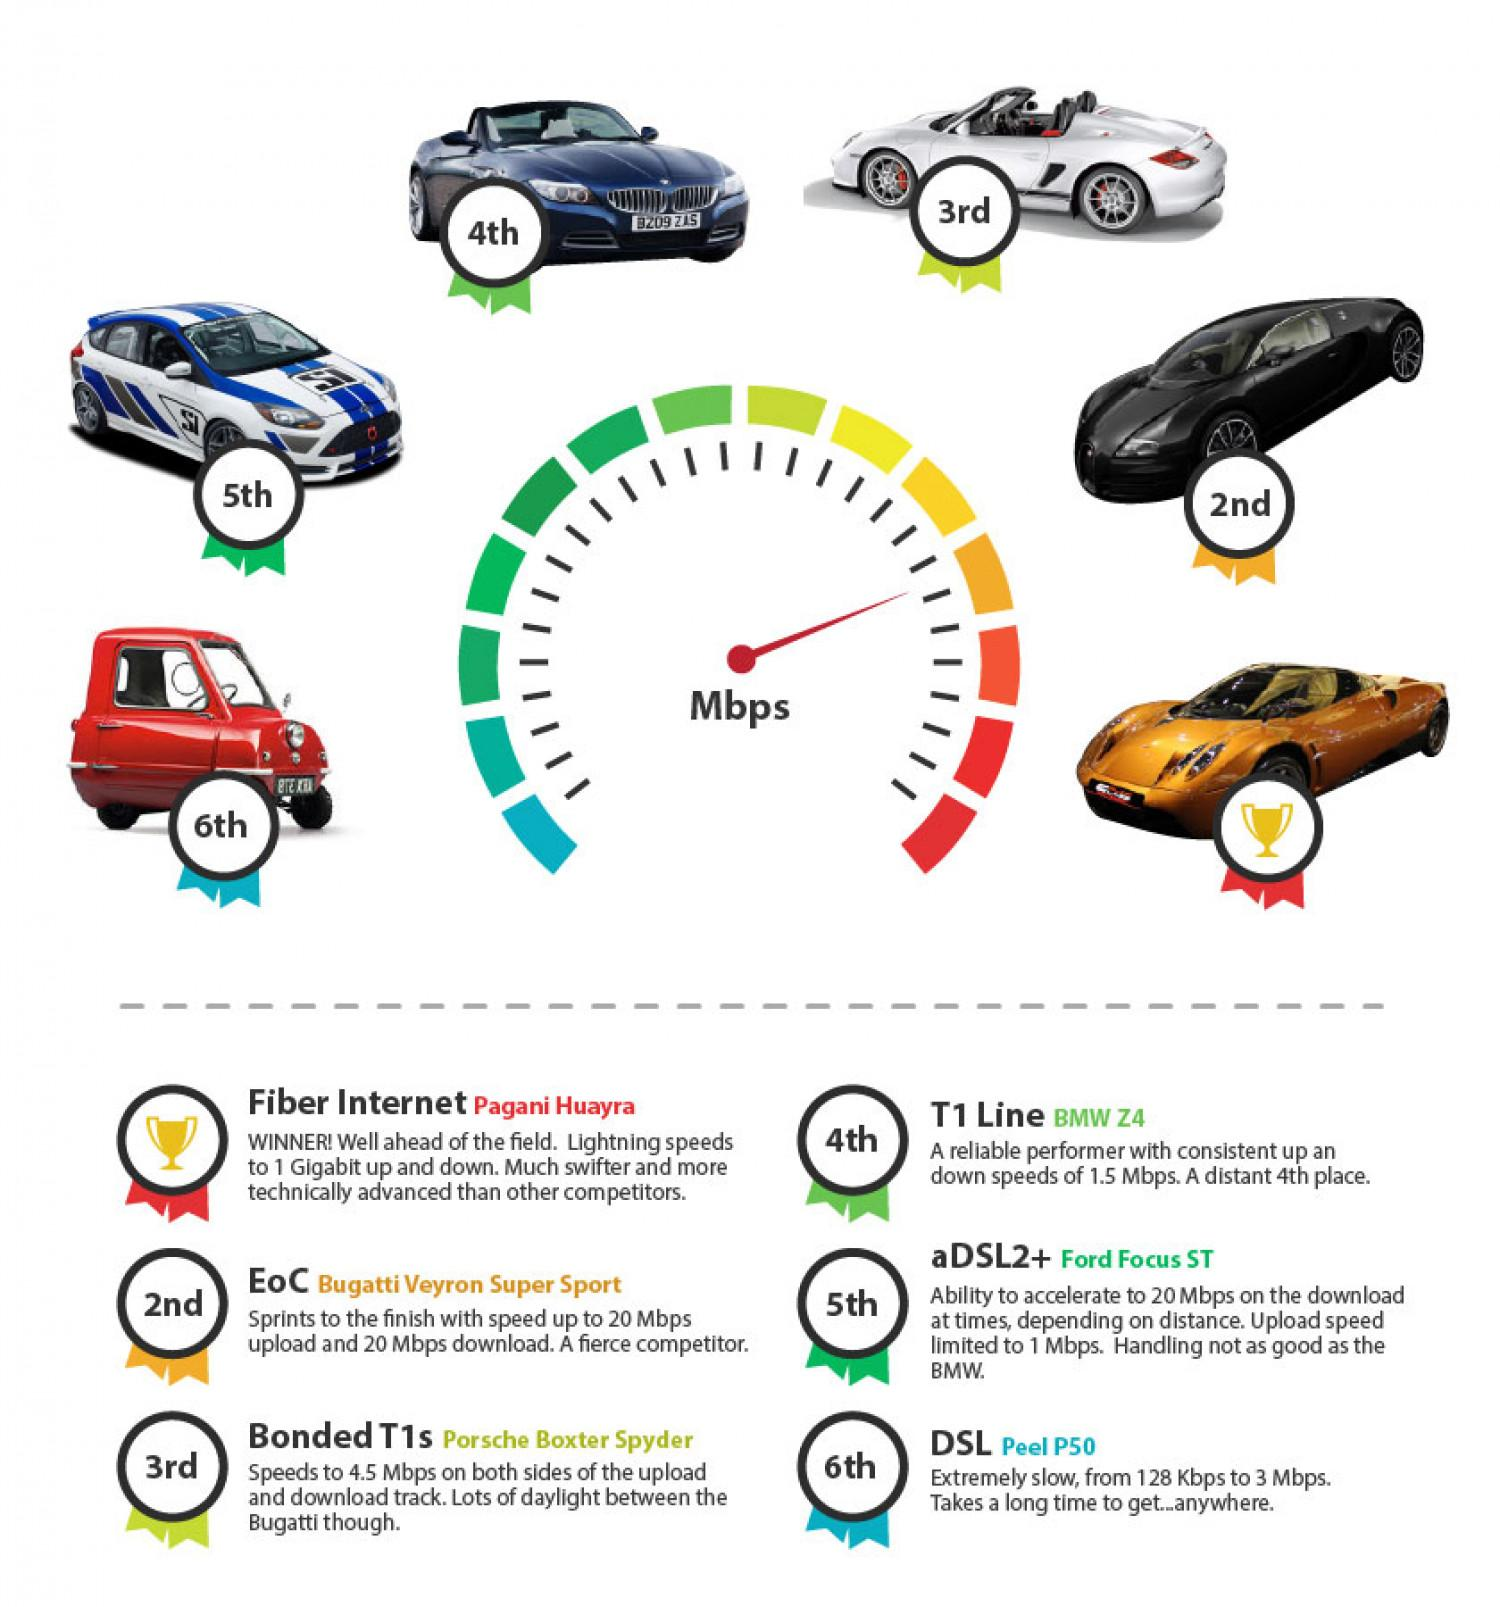Identify some key points in this picture. The white car depicted in the image is a Porsche Boxster Spyder. The color of the car that is first in terms of speed is orange. Six internet service providers are top performers in terms of speed, according to... The black car in the image represents a service provider, and it is not known which specific provider it is. The Pagani Huayra represents the internet service provider with the highest download and upload speeds. 